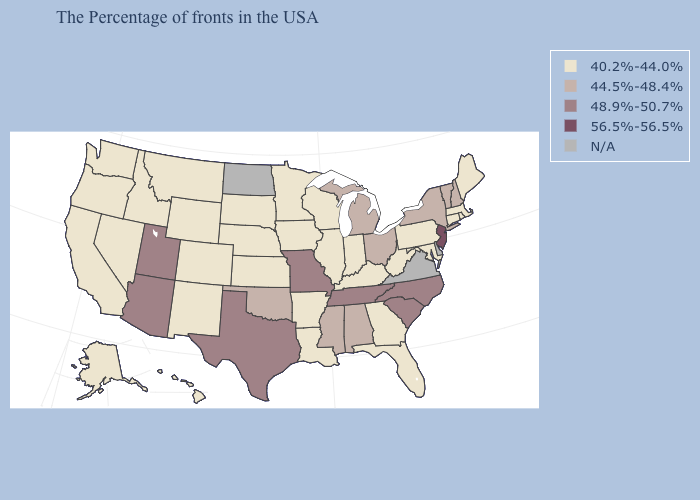What is the value of North Carolina?
Keep it brief. 48.9%-50.7%. Which states have the highest value in the USA?
Concise answer only. New Jersey. Name the states that have a value in the range 44.5%-48.4%?
Concise answer only. New Hampshire, Vermont, New York, Ohio, Michigan, Alabama, Mississippi, Oklahoma. Name the states that have a value in the range N/A?
Short answer required. Delaware, Virginia, North Dakota. What is the highest value in the MidWest ?
Keep it brief. 48.9%-50.7%. Does the map have missing data?
Give a very brief answer. Yes. What is the value of South Dakota?
Quick response, please. 40.2%-44.0%. Name the states that have a value in the range 44.5%-48.4%?
Quick response, please. New Hampshire, Vermont, New York, Ohio, Michigan, Alabama, Mississippi, Oklahoma. Does Connecticut have the lowest value in the USA?
Write a very short answer. Yes. What is the highest value in the MidWest ?
Quick response, please. 48.9%-50.7%. Name the states that have a value in the range 44.5%-48.4%?
Keep it brief. New Hampshire, Vermont, New York, Ohio, Michigan, Alabama, Mississippi, Oklahoma. What is the value of Illinois?
Short answer required. 40.2%-44.0%. What is the value of Wyoming?
Give a very brief answer. 40.2%-44.0%. Name the states that have a value in the range N/A?
Give a very brief answer. Delaware, Virginia, North Dakota. 